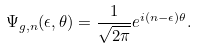Convert formula to latex. <formula><loc_0><loc_0><loc_500><loc_500>\Psi _ { g , n } ( \epsilon , \theta ) = \frac { 1 } { \sqrt { 2 \pi } } e ^ { i ( n - \epsilon ) \theta } .</formula> 